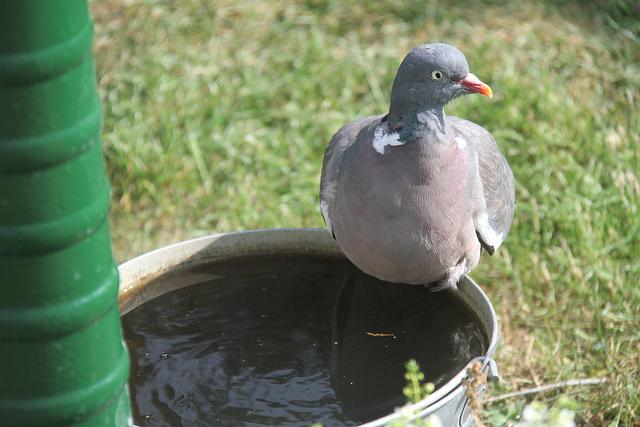How many birds are there?
Write a very short answer. 1. How many cats?
Be succinct. 0. What animal is this?
Keep it brief. Bird. What color is the bird's beak?
Short answer required. Orange. Are there bird feathers scattered around?
Give a very brief answer. No. Can this bird fly?
Concise answer only. Yes. What type of bird is this?
Short answer required. Pigeon. What is in the dish with the bird?
Quick response, please. Water. What is the bird standing on?
Give a very brief answer. Bucket. What colors make up the bird's coat?
Quick response, please. Gray and white. 